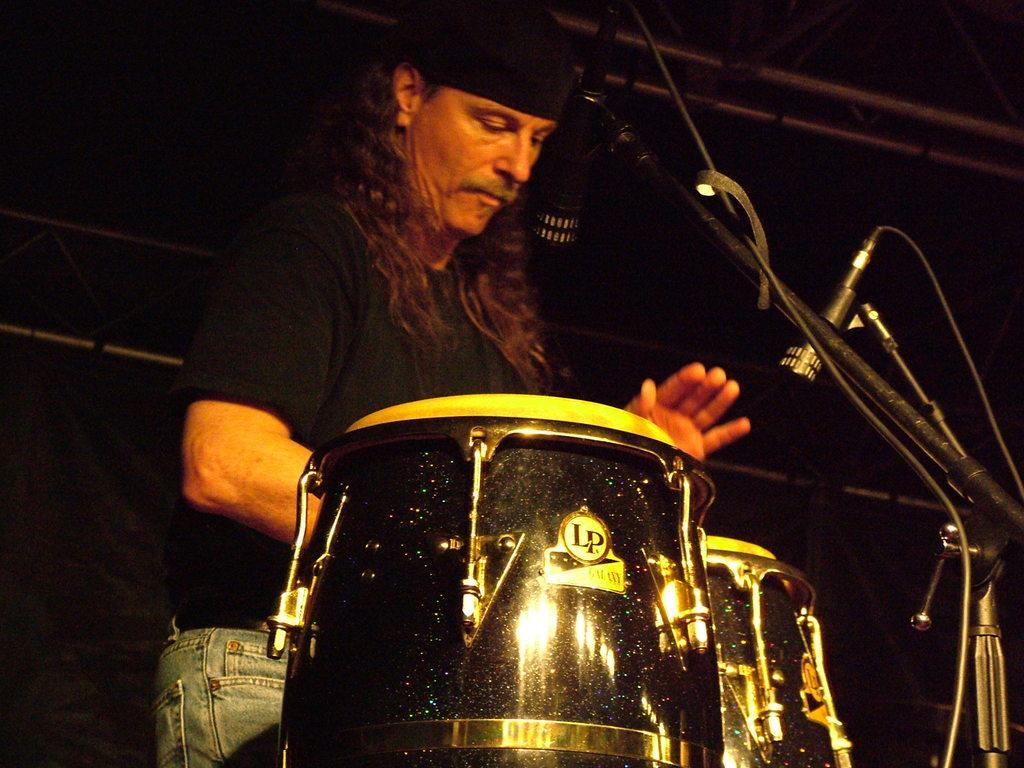What is the man in the image doing? The man is playing a drum in the image. What object is near the man in the image? There is a microphone in the bottom right side of the image. What can be seen in the top right side of the image? There is a roof visible in the top right side of the image. What type of dress is the man wearing in the image? The man is not wearing a dress in the image; he is playing a drum. 